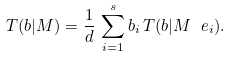<formula> <loc_0><loc_0><loc_500><loc_500>T ( b | M ) = \frac { 1 } { d } \, \sum _ { i = 1 } ^ { s } b _ { i } \, T ( b | M \ e _ { i } ) .</formula> 